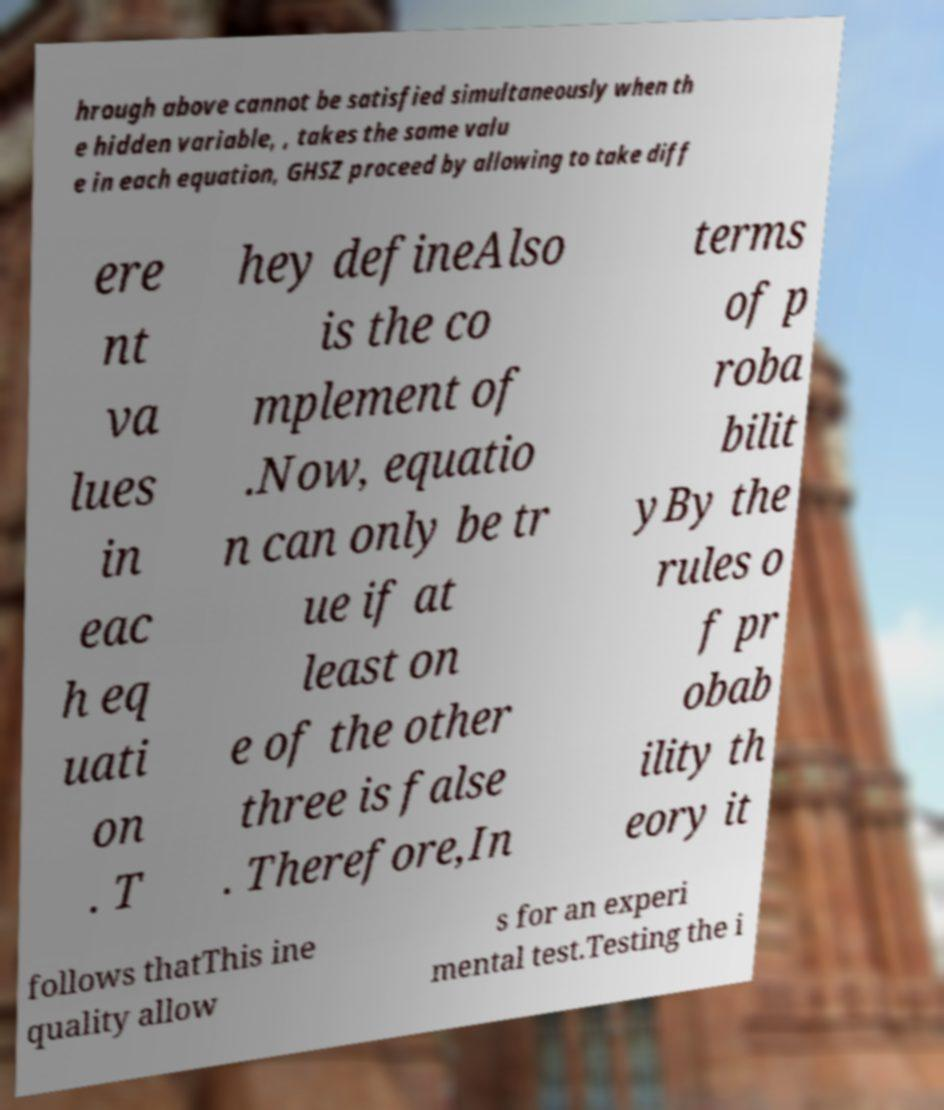Can you read and provide the text displayed in the image?This photo seems to have some interesting text. Can you extract and type it out for me? hrough above cannot be satisfied simultaneously when th e hidden variable, , takes the same valu e in each equation, GHSZ proceed by allowing to take diff ere nt va lues in eac h eq uati on . T hey defineAlso is the co mplement of .Now, equatio n can only be tr ue if at least on e of the other three is false . Therefore,In terms of p roba bilit yBy the rules o f pr obab ility th eory it follows thatThis ine quality allow s for an experi mental test.Testing the i 